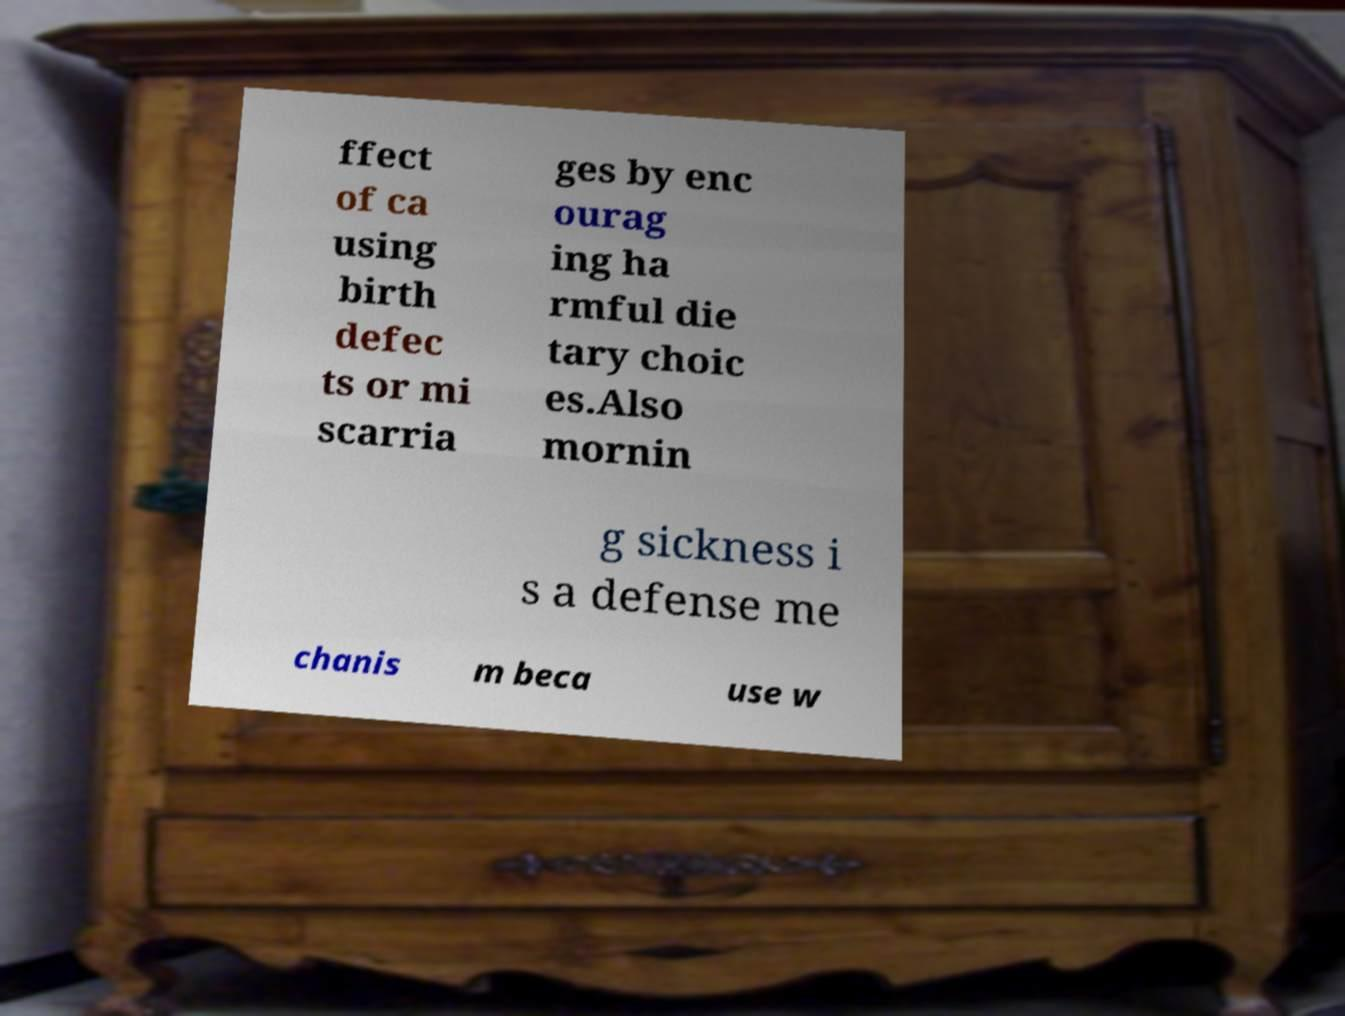Please read and relay the text visible in this image. What does it say? ffect of ca using birth defec ts or mi scarria ges by enc ourag ing ha rmful die tary choic es.Also mornin g sickness i s a defense me chanis m beca use w 